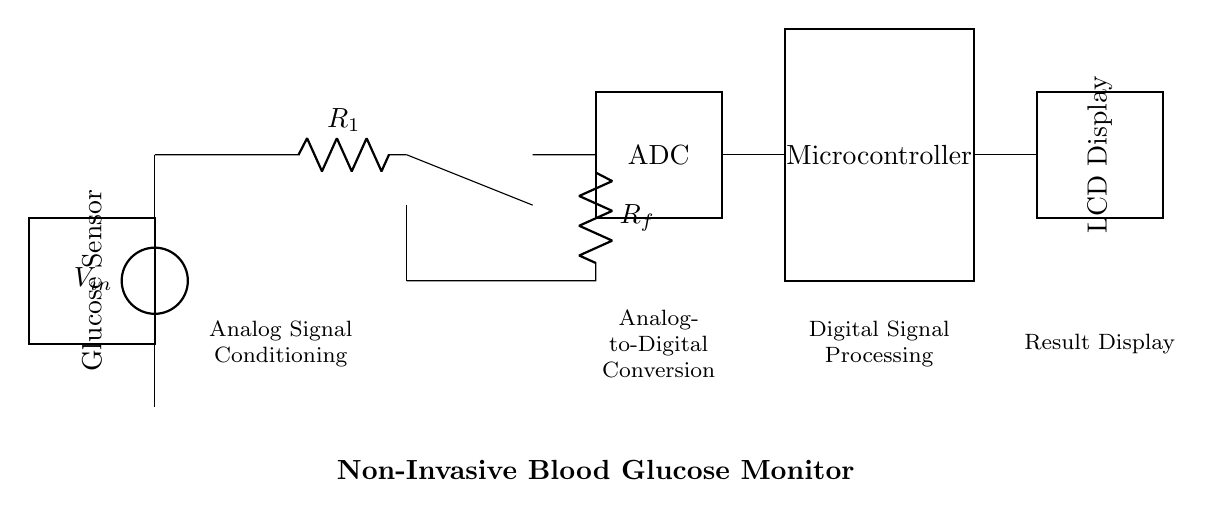What is the type of the first component in the circuit? The first component is a voltage source, denoted by V_in, providing the required supply voltage for the circuit.
Answer: Voltage source What function does the operational amplifier serve in this circuit? The operational amplifier is used for signal amplification. It collects the analog signal from the sensor and amplifies it for further processing.
Answer: Signal amplification What is the main purpose of the ADC in the circuit? The ADC (Analog-to-Digital Converter) transforms the analog signals from the operational amplifier into digital form for processing by the microcontroller.
Answer: Conversion of analog to digital How many passive components are there in the analog section of the circuit? There are two resistors, R_1 and R_f, which are passive components used in the analog signal conditioning part.
Answer: Two What is the purpose of the glucose sensor in this circuit? The glucose sensor is responsible for detecting the blood glucose level through non-invasive means, measuring specific physiological parameters.
Answer: Detection of glucose levels Which component displays the result of the blood glucose measurement? The LCD Display receives the processed digital signal from the microcontroller and presents the blood glucose level to the user in a readable format.
Answer: LCD Display What indicates the transition from the analog section to the digital section in this circuit? The ADC module serves as the bridge between the analog signal conditioning section and the digital signal processing section, indicating this transition.
Answer: ADC 